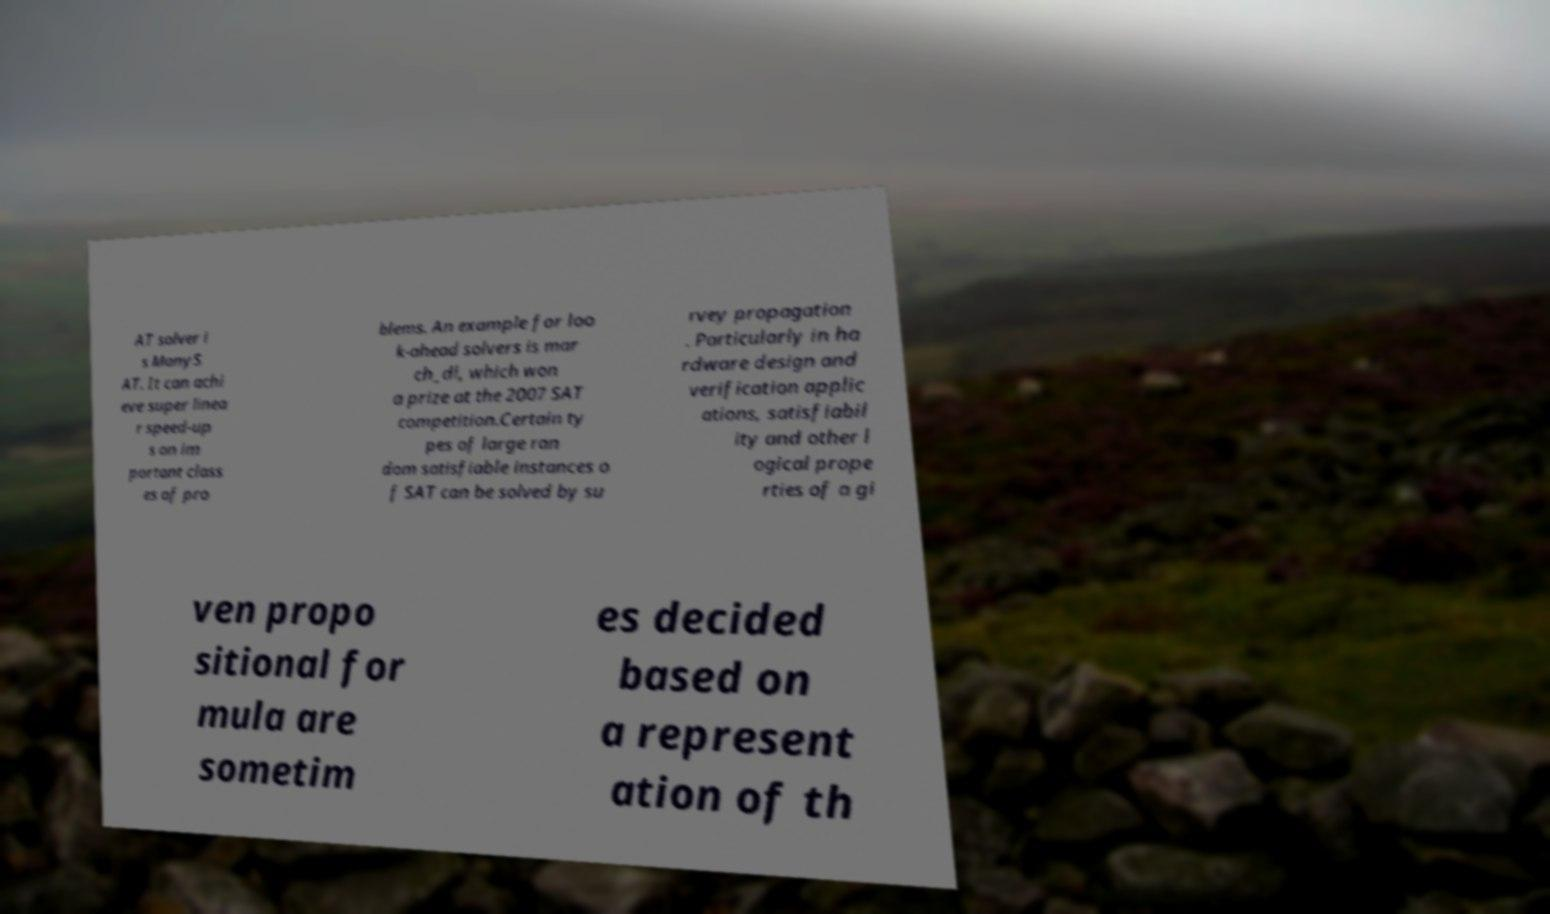Could you assist in decoding the text presented in this image and type it out clearly? AT solver i s ManyS AT. It can achi eve super linea r speed-up s on im portant class es of pro blems. An example for loo k-ahead solvers is mar ch_dl, which won a prize at the 2007 SAT competition.Certain ty pes of large ran dom satisfiable instances o f SAT can be solved by su rvey propagation . Particularly in ha rdware design and verification applic ations, satisfiabil ity and other l ogical prope rties of a gi ven propo sitional for mula are sometim es decided based on a represent ation of th 